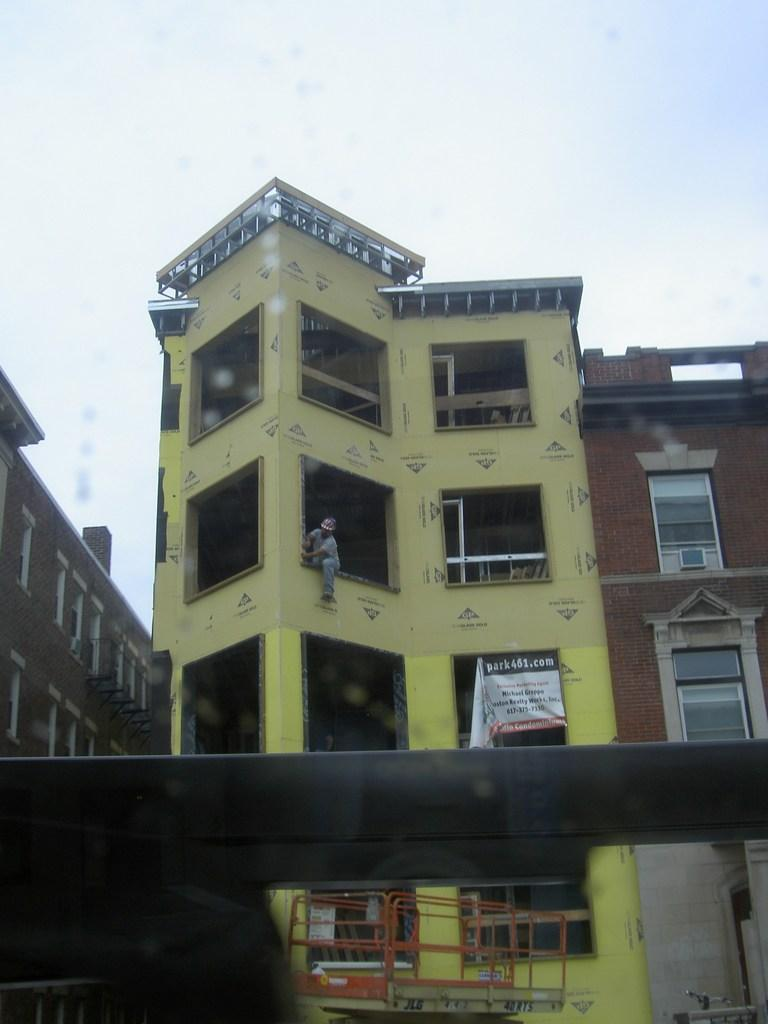What type of structures can be seen in the image? There are buildings in the image. Can you describe the person in the image? There is a person in the image. What is hanging or displayed in the image? There is a banner in the image. What can be seen in the background of the image? The sky is visible in the background of the image. How many birds are perched on the banner in the image? There is no mention of birds in the provided facts, so we cannot determine if they are present in the image. 